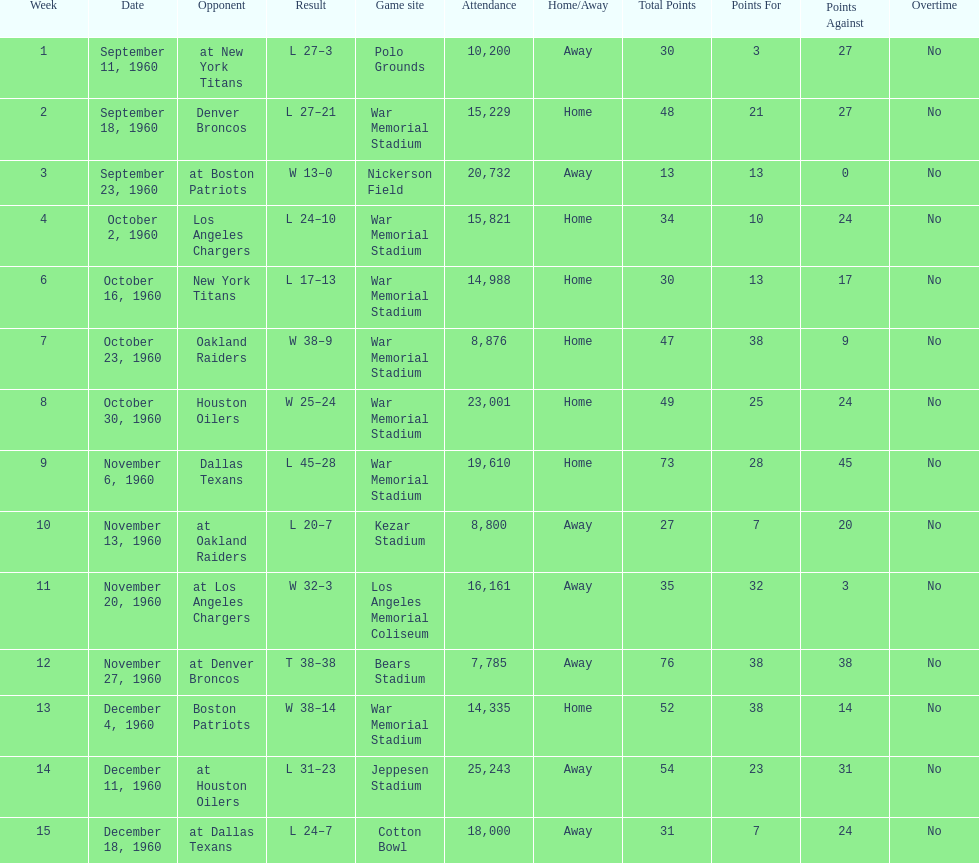What date was the first game at war memorial stadium? September 18, 1960. 